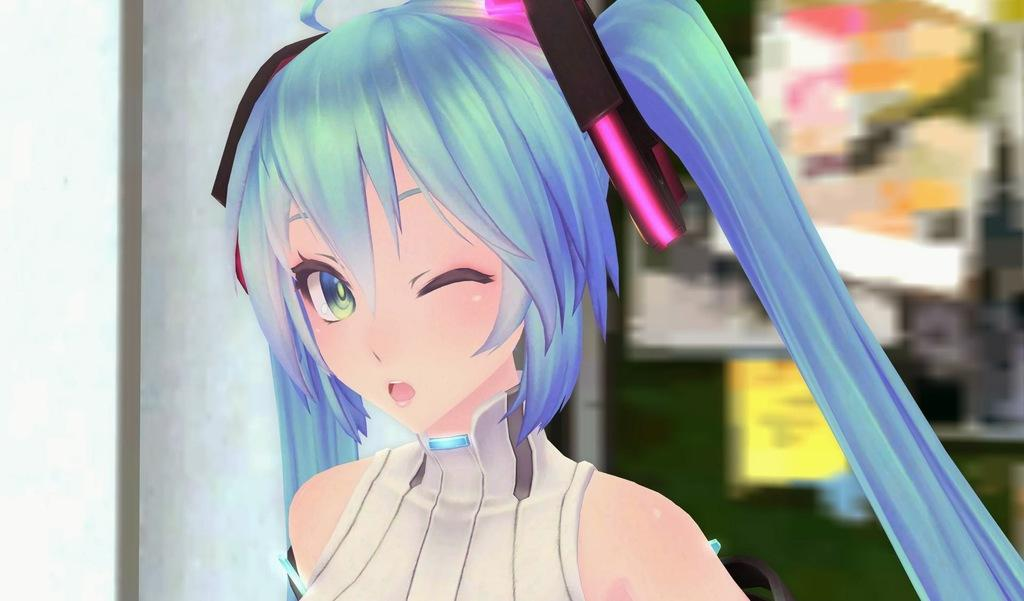Who is the main subject in the image? There is a girl in the image. What can be observed about the girl's attire? The girl is wearing clothes. What type of coast can be seen in the image? There is no coast visible in the image; it features a girl wearing clothes. Who is the expert in the image? There is no expert present in the image; it features a girl wearing clothes. 